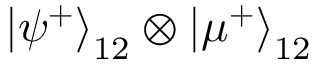<formula> <loc_0><loc_0><loc_500><loc_500>\left | \psi ^ { + } \right \rangle _ { 1 2 } \otimes \left | \mu ^ { + } \right \rangle _ { 1 2 }</formula> 